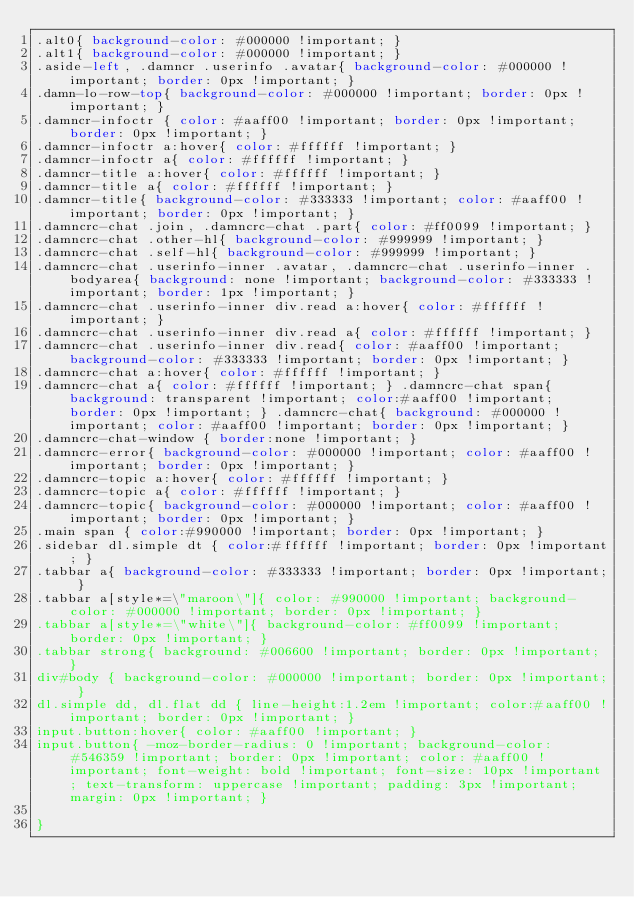Convert code to text. <code><loc_0><loc_0><loc_500><loc_500><_CSS_>.alt0{ background-color: #000000 !important; } 
.alt1{ background-color: #000000 !important; } 
.aside-left, .damncr .userinfo .avatar{ background-color: #000000 !important; border: 0px !important; } 
.damn-lo-row-top{ background-color: #000000 !important; border: 0px !important; } 
.damncr-infoctr { color: #aaff00 !important; border: 0px !important; border: 0px !important; } 
.damncr-infoctr a:hover{ color: #ffffff !important; } 
.damncr-infoctr a{ color: #ffffff !important; } 
.damncr-title a:hover{ color: #ffffff !important; } 
.damncr-title a{ color: #ffffff !important; } 
.damncr-title{ background-color: #333333 !important; color: #aaff00 !important; border: 0px !important; } 
.damncrc-chat .join, .damncrc-chat .part{ color: #ff0099 !important; } 
.damncrc-chat .other-hl{ background-color: #999999 !important; } 
.damncrc-chat .self-hl{ background-color: #999999 !important; } 
.damncrc-chat .userinfo-inner .avatar, .damncrc-chat .userinfo-inner .bodyarea{ background: none !important; background-color: #333333 !important; border: 1px !important; } 
.damncrc-chat .userinfo-inner div.read a:hover{ color: #ffffff !important; } 
.damncrc-chat .userinfo-inner div.read a{ color: #ffffff !important; } 
.damncrc-chat .userinfo-inner div.read{ color: #aaff00 !important; background-color: #333333 !important; border: 0px !important; } 
.damncrc-chat a:hover{ color: #ffffff !important; } 
.damncrc-chat a{ color: #ffffff !important; } .damncrc-chat span{ background: transparent !important; color:#aaff00 !important; border: 0px !important; } .damncrc-chat{ background: #000000 !important; color: #aaff00 !important; border: 0px !important; } 
.damncrc-chat-window { border:none !important; } 
.damncrc-error{ background-color: #000000 !important; color: #aaff00 !important; border: 0px !important; } 
.damncrc-topic a:hover{ color: #ffffff !important; } 
.damncrc-topic a{ color: #ffffff !important; } 
.damncrc-topic{ background-color: #000000 !important; color: #aaff00 !important; border: 0px !important; } 
.main span { color:#990000 !important; border: 0px !important; } 
.sidebar dl.simple dt { color:#ffffff !important; border: 0px !important; } 
.tabbar a{ background-color: #333333 !important; border: 0px !important; } 
.tabbar a[style*=\"maroon\"]{ color: #990000 !important; background-color: #000000 !important; border: 0px !important; } 
.tabbar a[style*=\"white\"]{ background-color: #ff0099 !important; border: 0px !important; } 
.tabbar strong{ background: #006600 !important; border: 0px !important; } 
div#body { background-color: #000000 !important; border: 0px !important; } 
dl.simple dd, dl.flat dd { line-height:1.2em !important; color:#aaff00 !important; border: 0px !important; } 
input.button:hover{ color: #aaff00 !important; } 
input.button{ -moz-border-radius: 0 !important; background-color: #546359 !important; border: 0px !important; color: #aaff00 !important; font-weight: bold !important; font-size: 10px !important; text-transform: uppercase !important; padding: 3px !important; margin: 0px !important; }

}</code> 